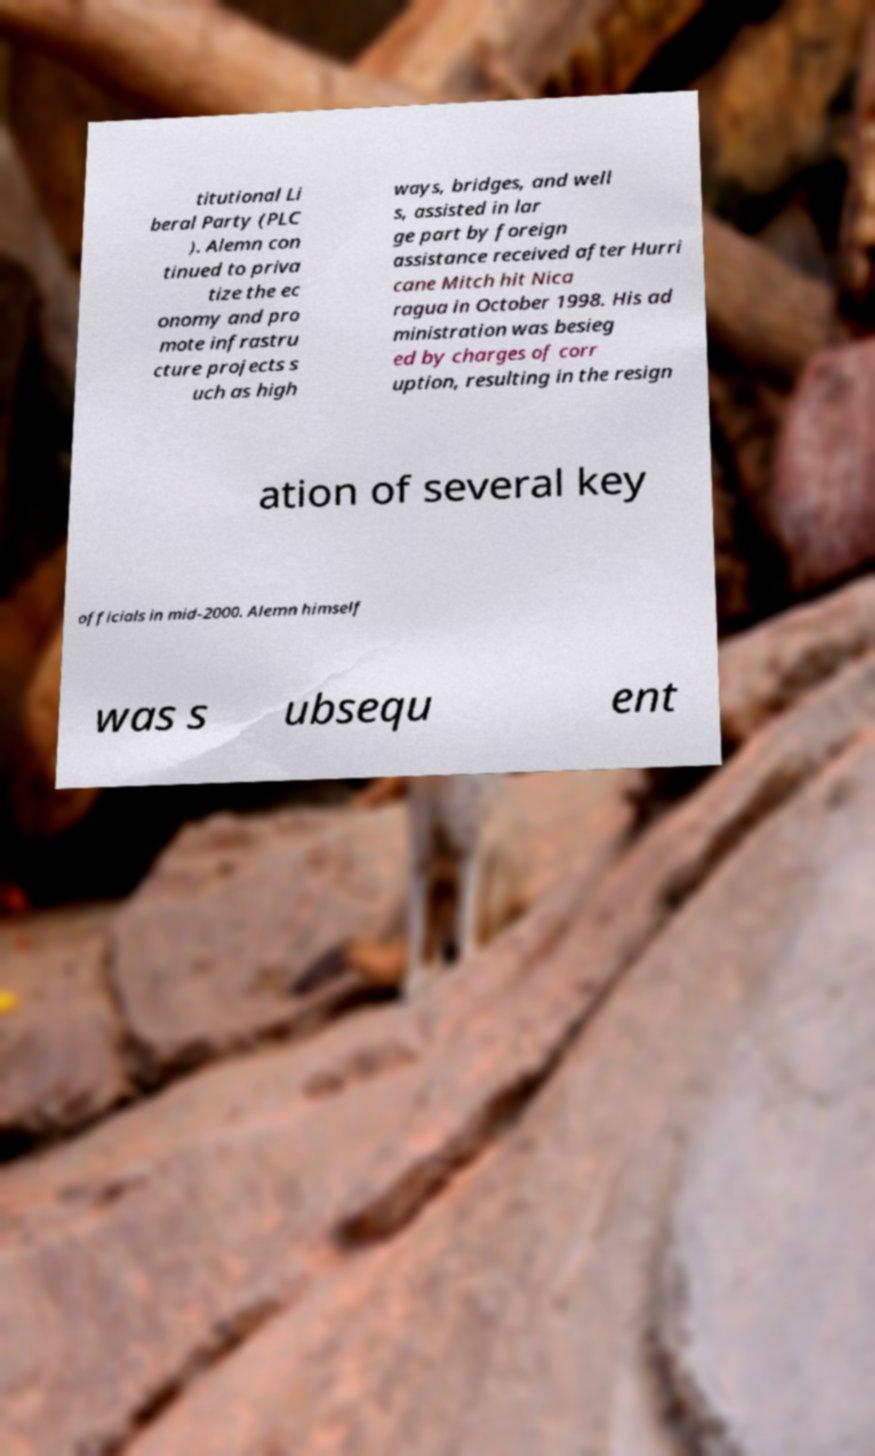For documentation purposes, I need the text within this image transcribed. Could you provide that? titutional Li beral Party (PLC ). Alemn con tinued to priva tize the ec onomy and pro mote infrastru cture projects s uch as high ways, bridges, and well s, assisted in lar ge part by foreign assistance received after Hurri cane Mitch hit Nica ragua in October 1998. His ad ministration was besieg ed by charges of corr uption, resulting in the resign ation of several key officials in mid-2000. Alemn himself was s ubsequ ent 